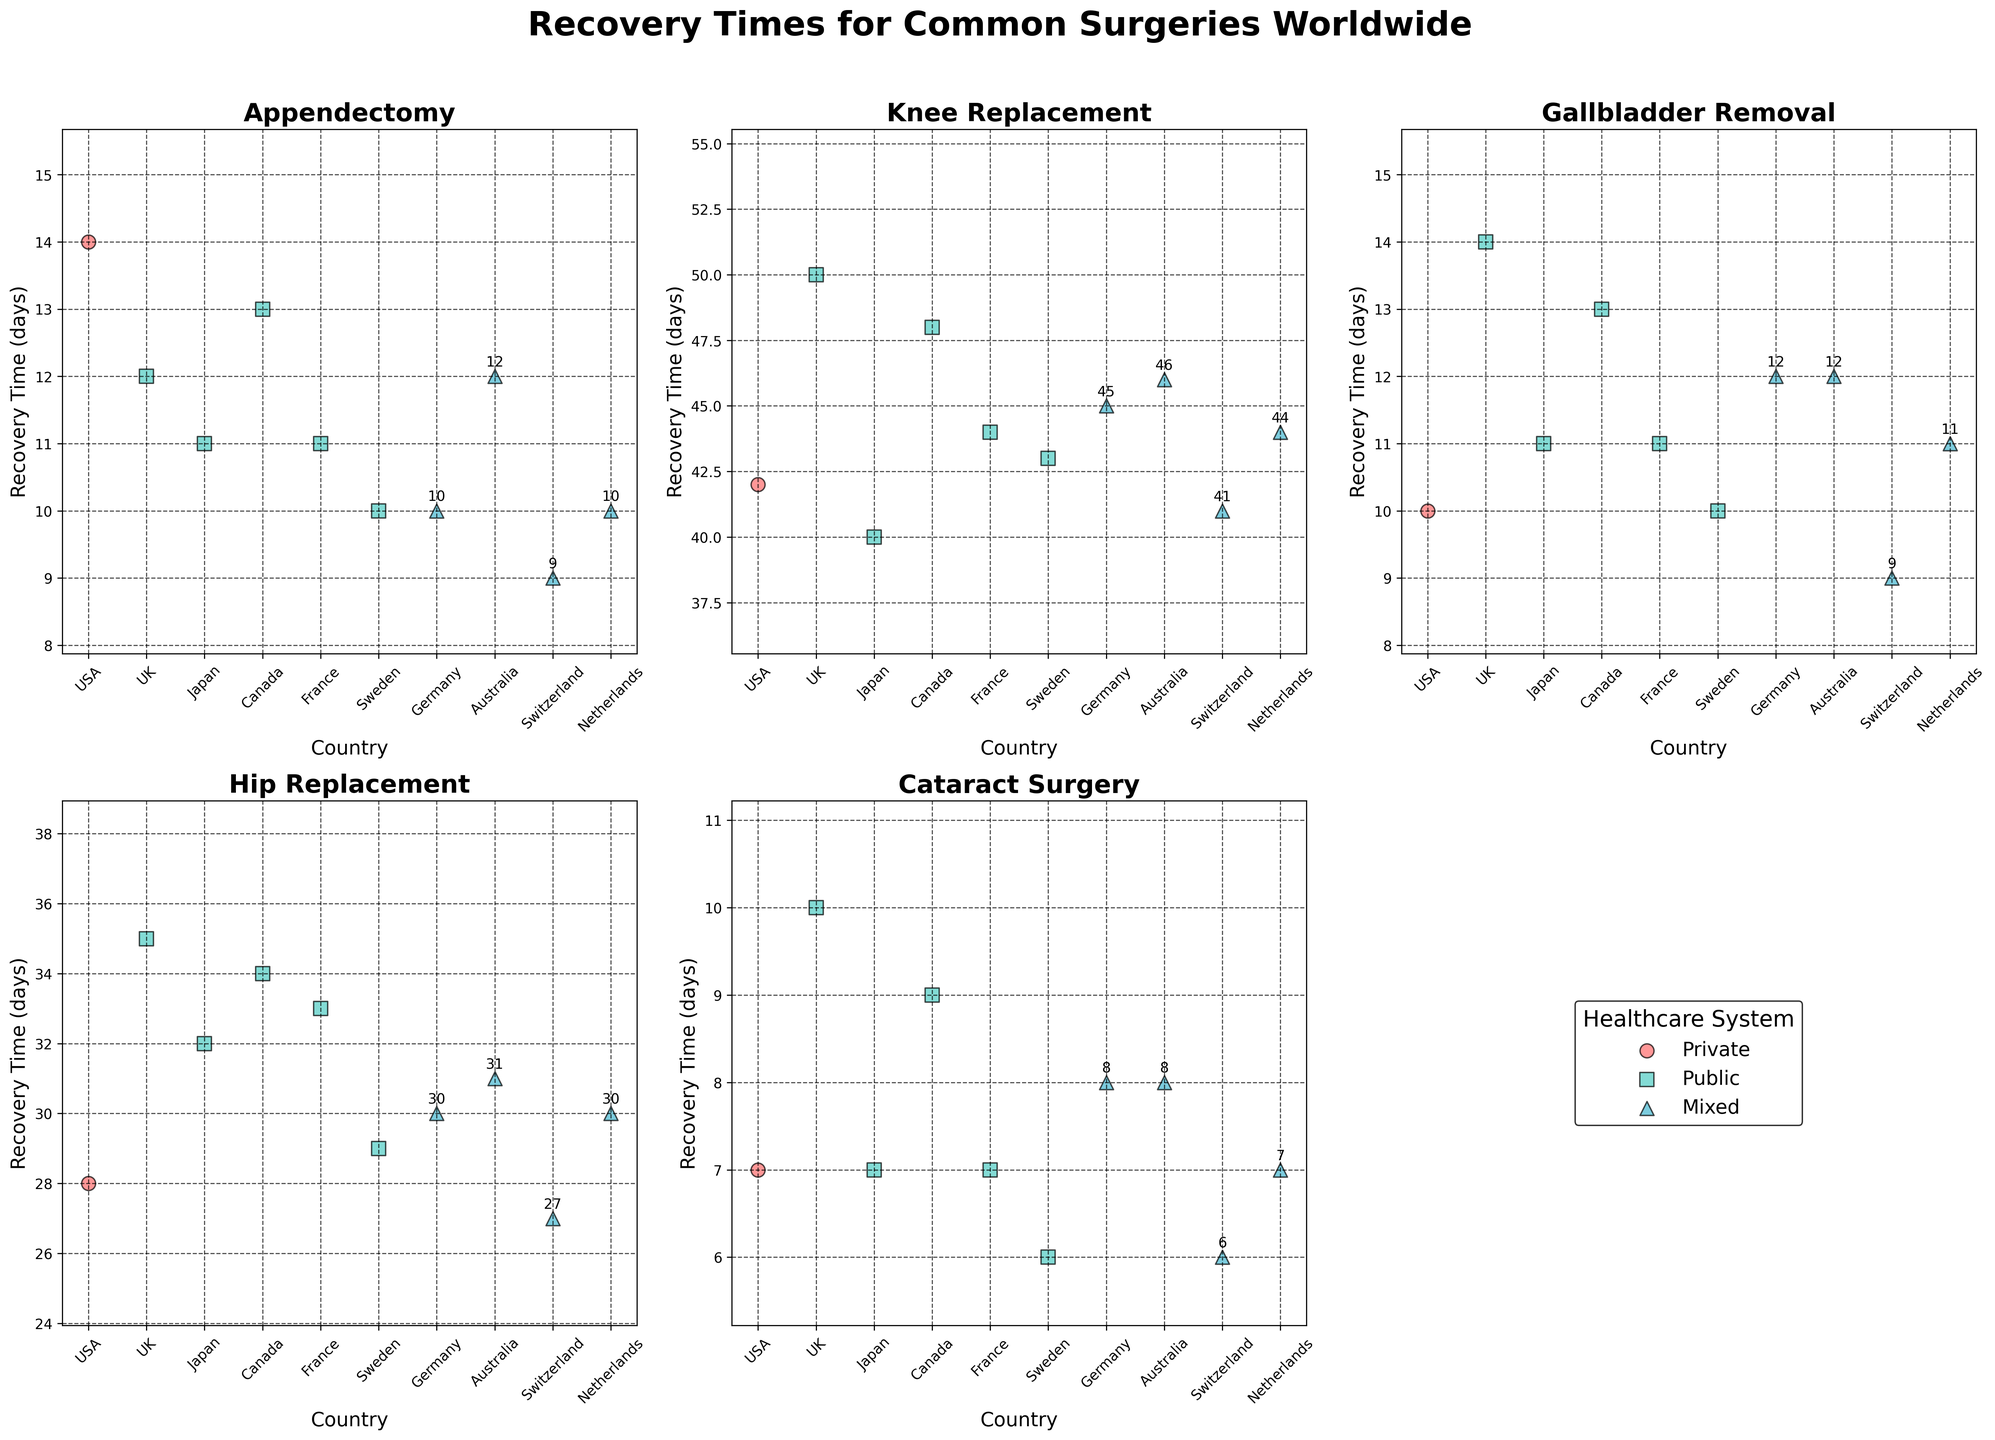Which country has the shortest recovery time for Knee Replacement surgery? Identify from the plot the country with the lowest recovery time for Knee Replacement surgery. Switzerland has a recovery time of 41 days for Knee Replacement surgery, which is the shortest.
Answer: Switzerland Which healthcare system generally shows the lowest recovery times across all surgeries? Compare the recovery times for the Private, Public, and Mixed healthcare systems across all the subplots. The Mixed healthcare system often shows the lowest recovery times.
Answer: Mixed What is the difference in recovery time for Hip Replacement surgery between the USA and the UK? Find the recovery times for Hip Replacement surgery for both countries and subtract the UK value from the USA value. USA has 28 days, and the UK has 35 days, so the difference is 35 - 28 = 7 days.
Answer: 7 days Among Appendectomy surgeries, which country with a Public healthcare system has the longest recovery time? Identify and compare all countries with a Public healthcare system for Appendectomy surgeries, finding the one with the highest recovery time. Canada has 13 days, which is the longest recovery time among countries with a Public healthcare system.
Answer: Canada What is the average recovery time for Cataract Surgery in countries with a Mixed healthcare system? Find the recovery times for Cataract Surgery in countries with a Mixed healthcare system and calculate the average. The recovery times are Germany (8), Australia (8), Switzerland (6), and Netherlands (7). The average is (8 + 8 + 6 + 7) / 4 = 7.25 days.
Answer: 7.25 days Which surgery type shows the most variation in recovery times across different healthcare systems? Visually compare the range (difference between the highest and lowest recovery times) for each surgery type across different healthcare systems. Knee Replacement shows the most variation, ranging from 40 days to 50 days.
Answer: Knee Replacement For Gallbladder Removal surgery, how much shorter is the recovery time in Switzerland compared to Canada? Identify the recovery times for Gallbladder Removal surgery in Switzerland and Canada and subtract the Switzerland value from the Canada value. Switzerland has 9 days, and Canada has 13 days, so the difference is 13 - 9 = 4 days.
Answer: 4 days In which country does Cataract Surgery have the shortest recovery time? Find the country with the lowest recovery time for Cataract Surgery by comparing all countries on the respective subplot. Sweden and Switzerland both have the shortest recovery time of 6 days for Cataract Surgery.
Answer: Sweden, Switzerland What is the combined total recovery time for all surgeries in the USA? Sum up the recovery times for all surgery types in the USA. The recovery times are Appendectomy (14), Knee Replacement (42), Gallbladder Removal (10), Hip Replacement (28), Cataract Surgery (7). The total is 14 + 42 + 10 + 28 + 7 = 101 days.
Answer: 101 days How do recovery times for Hip Replacement surgery in countries with a Mixed healthcare system compare to those with a Public healthcare system? Compare the average recovery times for Hip Replacement surgery in countries with Mixed and Public healthcare systems. Mixed: Germany (30), Australia (31), Switzerland (27), Netherlands (30). Public: UK (35), Japan (32), Canada (34), France (33), Sweden (29). Average Mixed: (30 + 31 + 27 + 30) / 4 = 29.5 days. Average Public: (35 + 32 + 34 + 33 + 29) / 5 = 32.6 days. Mixed has a shorter average recovery time than Public.
Answer: Mixed has shorter recovery times 